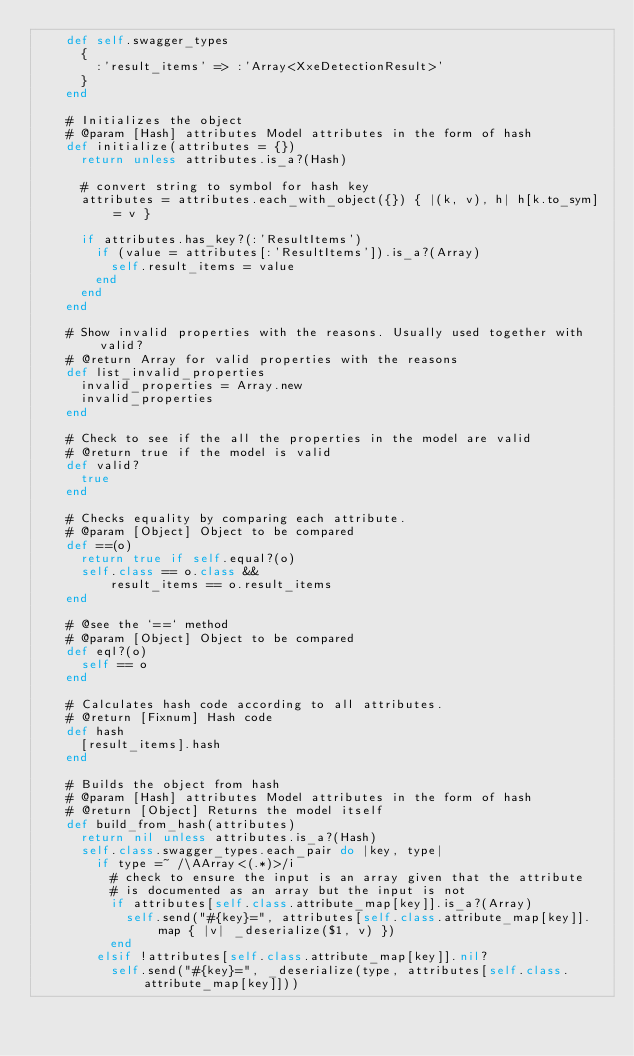<code> <loc_0><loc_0><loc_500><loc_500><_Ruby_>    def self.swagger_types
      {
        :'result_items' => :'Array<XxeDetectionResult>'
      }
    end

    # Initializes the object
    # @param [Hash] attributes Model attributes in the form of hash
    def initialize(attributes = {})
      return unless attributes.is_a?(Hash)

      # convert string to symbol for hash key
      attributes = attributes.each_with_object({}) { |(k, v), h| h[k.to_sym] = v }

      if attributes.has_key?(:'ResultItems')
        if (value = attributes[:'ResultItems']).is_a?(Array)
          self.result_items = value
        end
      end
    end

    # Show invalid properties with the reasons. Usually used together with valid?
    # @return Array for valid properties with the reasons
    def list_invalid_properties
      invalid_properties = Array.new
      invalid_properties
    end

    # Check to see if the all the properties in the model are valid
    # @return true if the model is valid
    def valid?
      true
    end

    # Checks equality by comparing each attribute.
    # @param [Object] Object to be compared
    def ==(o)
      return true if self.equal?(o)
      self.class == o.class &&
          result_items == o.result_items
    end

    # @see the `==` method
    # @param [Object] Object to be compared
    def eql?(o)
      self == o
    end

    # Calculates hash code according to all attributes.
    # @return [Fixnum] Hash code
    def hash
      [result_items].hash
    end

    # Builds the object from hash
    # @param [Hash] attributes Model attributes in the form of hash
    # @return [Object] Returns the model itself
    def build_from_hash(attributes)
      return nil unless attributes.is_a?(Hash)
      self.class.swagger_types.each_pair do |key, type|
        if type =~ /\AArray<(.*)>/i
          # check to ensure the input is an array given that the attribute
          # is documented as an array but the input is not
          if attributes[self.class.attribute_map[key]].is_a?(Array)
            self.send("#{key}=", attributes[self.class.attribute_map[key]].map { |v| _deserialize($1, v) })
          end
        elsif !attributes[self.class.attribute_map[key]].nil?
          self.send("#{key}=", _deserialize(type, attributes[self.class.attribute_map[key]]))</code> 